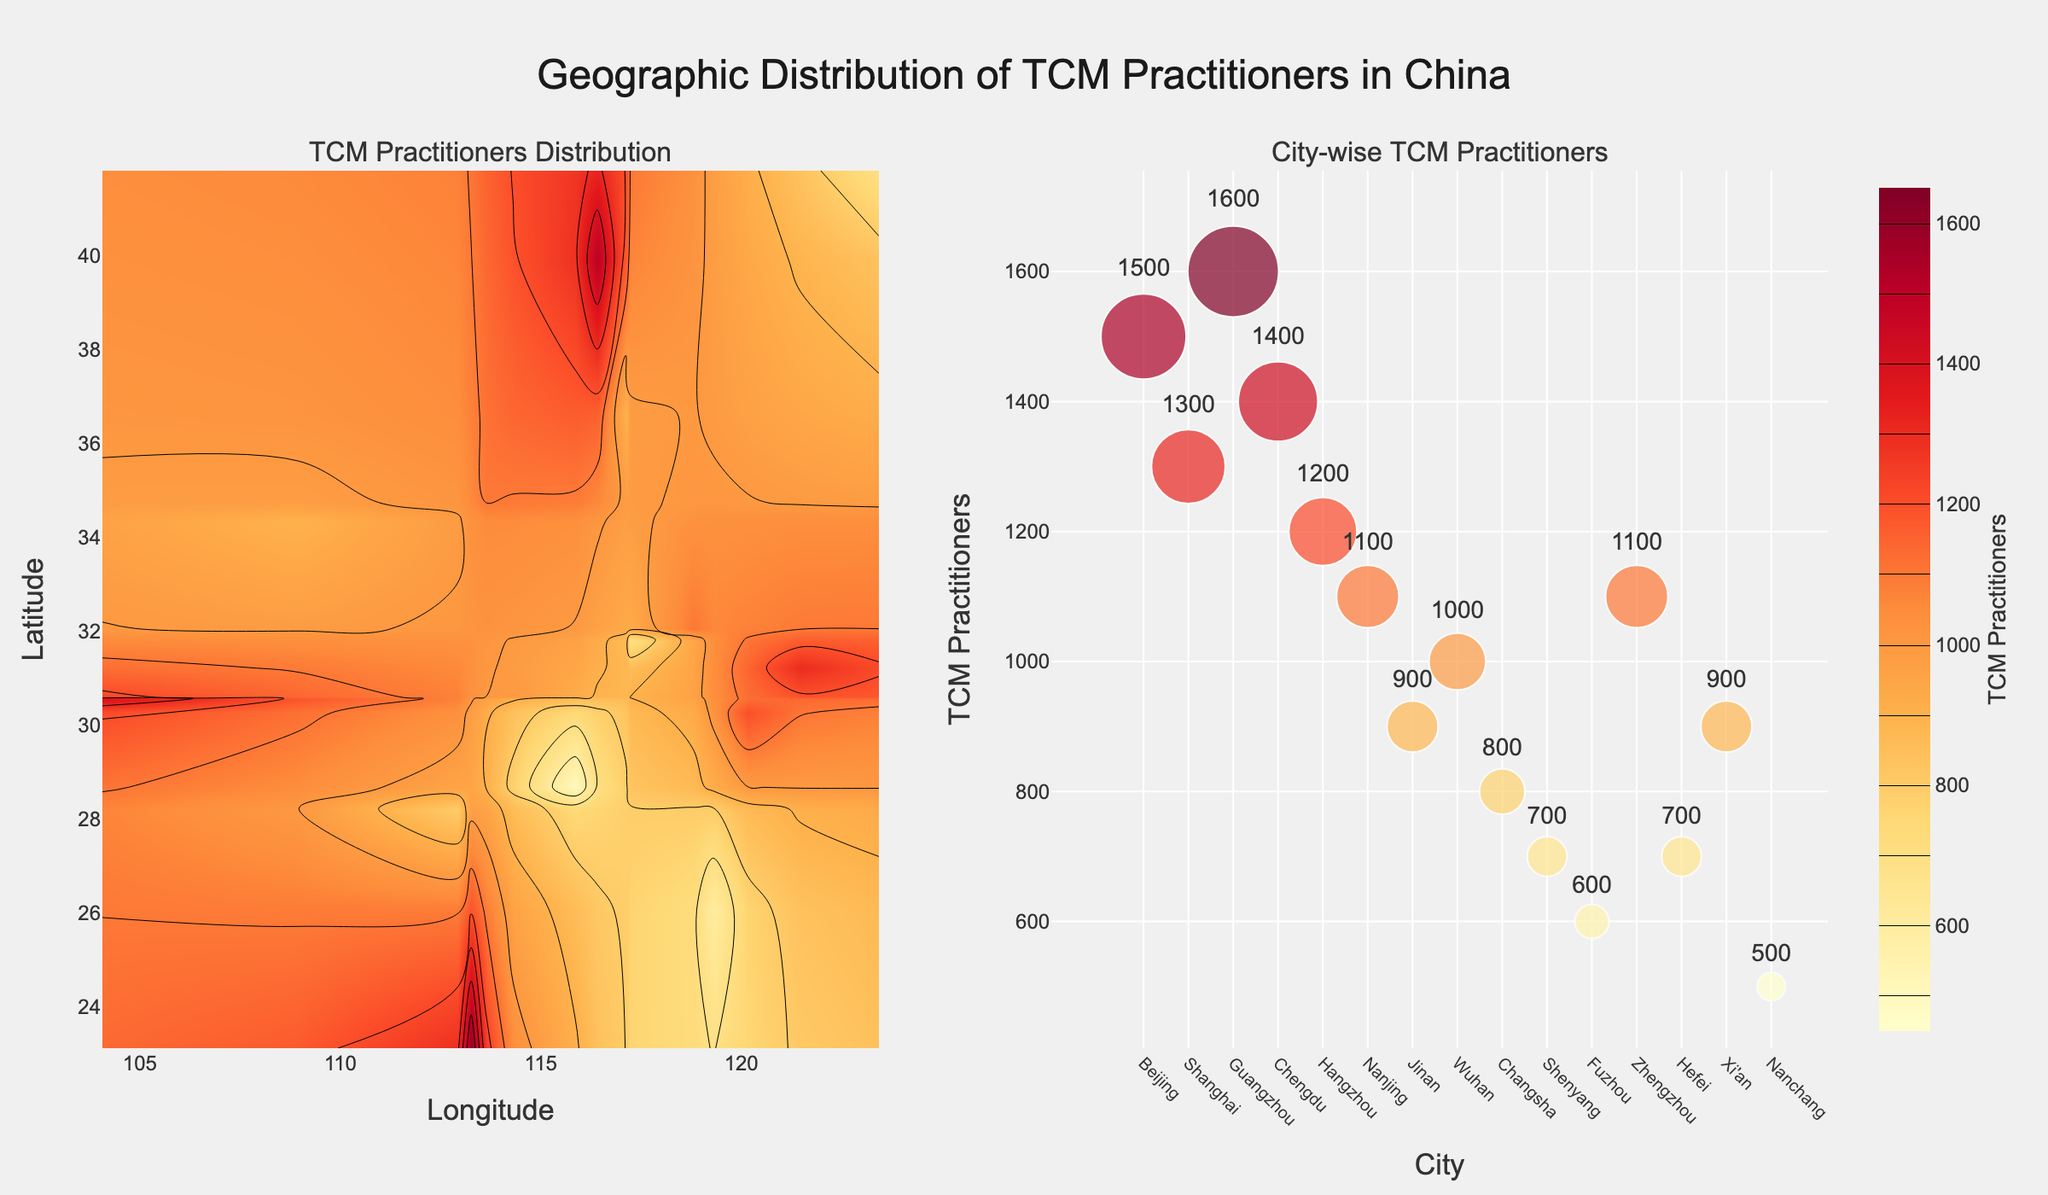What is the title of the figure? The title is usually located at the top of the figure. Here, it reads "Geographic Distribution of TCM Practitioners in China".
Answer: Geographic Distribution of TCM Practitioners in China Which city has the highest number of TCM practitioners? The scatter plot on the right shows the number of practitioners for each city. The city with the highest bar is Guangzhou with 1600 practitioners.
Answer: Guangzhou How many cities have fewer than 1000 TCM practitioners? By examining the scatter plot, you can count the number of cities where the number of practitioners is below 1000. These cities are Hunan, Liaoning, Fujian, Anhui, and Jiangxi, totaling 5 cities.
Answer: 5 Which province has nearly equal longitude and latitude values for its capital city? By looking at the contour plot on the left and checking longitudes and latitudes close to each other, it appears the province is Liaoning, with Shenyang near 41.8057 latitude and 123.4315 longitude.
Answer: Liaoning What is the difference in the number of TCM practitioners between the cities with the highest and lowest counts? The scatter plot shows that Guangzhou has the highest number (1600) and Jiangxi’s Nanchang has the lowest (500). The difference is 1600 - 500 = 1100.
Answer: 1100 What provinces show a high density of TCM practitioners centrally in the map? The contour plot shows the density of practitioners. High-density areas are the warmer colors found centrally, including Beijing, Shanghai, and Chengdu in Sichuan.
Answer: Beijing, Shanghai, Sichuan Which axis represents longitude in the contour plot? The x-axis is labeled "Longitude" in the contour plot on the left.
Answer: x-axis What is the median number of TCM practitioners among the listed cities? To find the median, you first list the numbers in order: 500, 600, 700, 700, 800, 900, 900, 1000, 1100, 1100, 1200, 1300, 1400, 1500, 1600. The middle number in this ordered list (8th value) is 1000.
Answer: 1000 Which city represented in the figure with longitude around 114 has about 1000 TCM practitioners? Checking the longitude values near 114, you find Hubei's Wuhan has a longitude of 114.3055 and about 1000 practitioners.
Answer: Wuhan Which cities are represented in the figure with latitudes less than 30? The contour plot indicates the cities with latitude less than 30 are Guangzhou, Hangzhou, and Fuzhou.
Answer: Guangzhou, Hangzhou, Fuzhou 